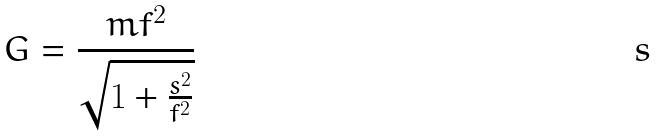Convert formula to latex. <formula><loc_0><loc_0><loc_500><loc_500>G = \frac { m f ^ { 2 } } { \sqrt { 1 + \frac { s ^ { 2 } } { f ^ { 2 } } } }</formula> 